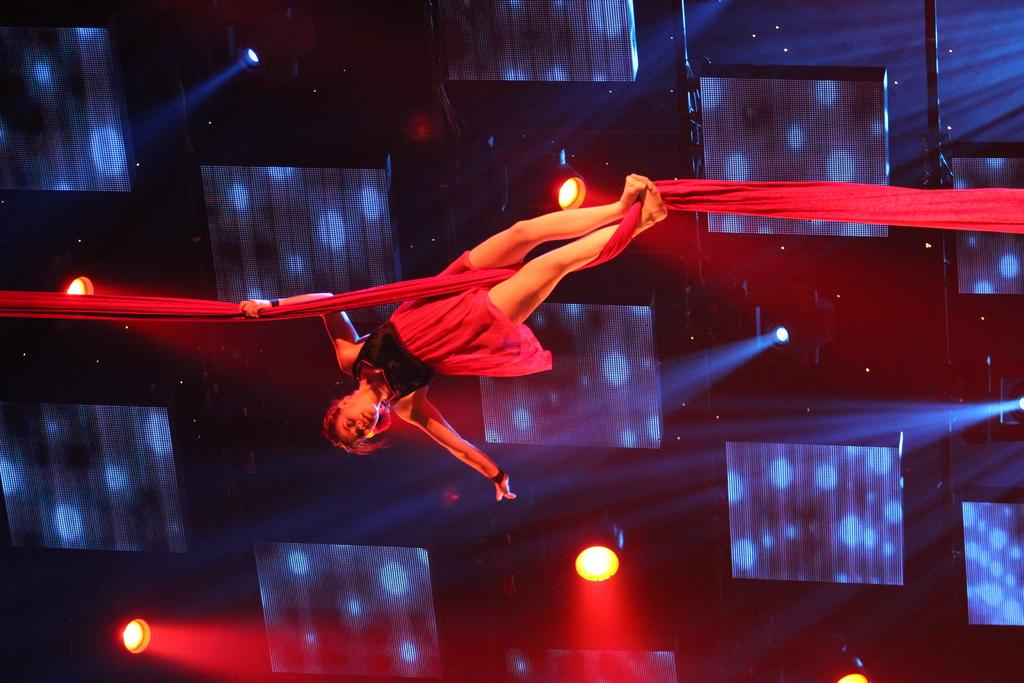Who is the main subject in the image? There is a girl in the image. What is the girl holding in the image? The girl is holding a cloth in the image. How is the girl positioned in the image? The girl appears to be in the air in the image. What can be seen in the background of the image? There are lights visible in the background of the image. How many bikes are parked near the river in the image? There is no mention of bikes or a river in the image; it features a girl in the air holding a cloth. 